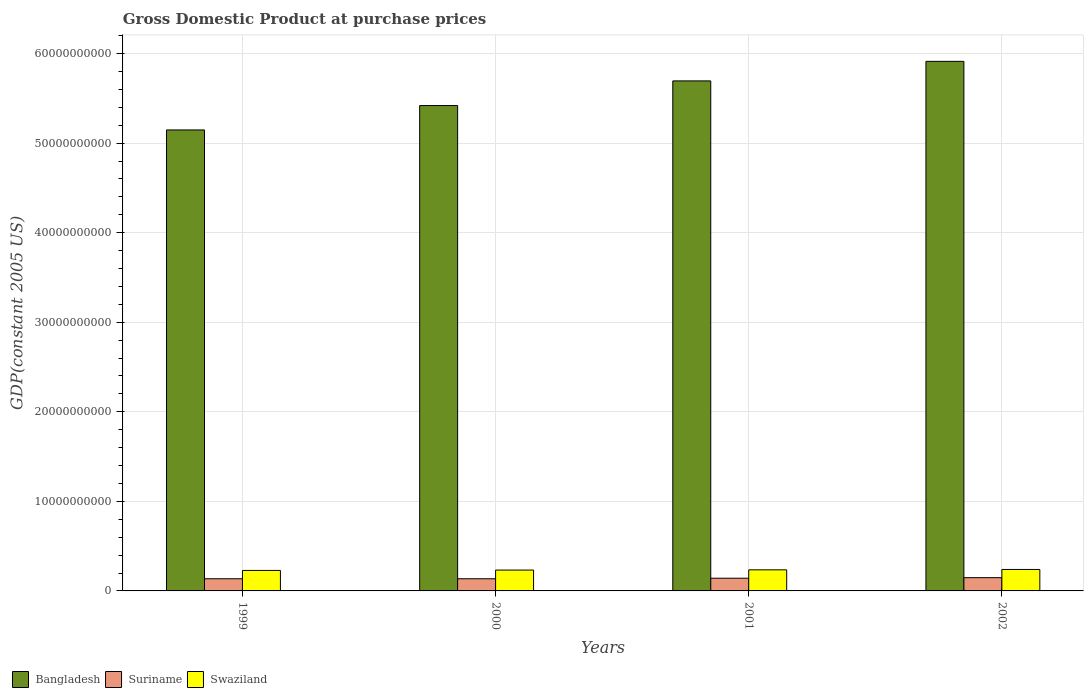How many different coloured bars are there?
Ensure brevity in your answer.  3. Are the number of bars on each tick of the X-axis equal?
Keep it short and to the point. Yes. How many bars are there on the 1st tick from the right?
Provide a succinct answer. 3. In how many cases, is the number of bars for a given year not equal to the number of legend labels?
Your answer should be very brief. 0. What is the GDP at purchase prices in Bangladesh in 1999?
Your answer should be very brief. 5.15e+1. Across all years, what is the maximum GDP at purchase prices in Swaziland?
Your answer should be compact. 2.40e+09. Across all years, what is the minimum GDP at purchase prices in Suriname?
Keep it short and to the point. 1.36e+09. In which year was the GDP at purchase prices in Suriname minimum?
Offer a very short reply. 2000. What is the total GDP at purchase prices in Swaziland in the graph?
Your answer should be compact. 9.37e+09. What is the difference between the GDP at purchase prices in Bangladesh in 1999 and that in 2001?
Offer a terse response. -5.48e+09. What is the difference between the GDP at purchase prices in Bangladesh in 2002 and the GDP at purchase prices in Suriname in 1999?
Ensure brevity in your answer.  5.78e+1. What is the average GDP at purchase prices in Suriname per year?
Keep it short and to the point. 1.40e+09. In the year 2000, what is the difference between the GDP at purchase prices in Suriname and GDP at purchase prices in Bangladesh?
Your answer should be very brief. -5.28e+1. What is the ratio of the GDP at purchase prices in Suriname in 2001 to that in 2002?
Provide a succinct answer. 0.96. Is the difference between the GDP at purchase prices in Suriname in 2000 and 2001 greater than the difference between the GDP at purchase prices in Bangladesh in 2000 and 2001?
Keep it short and to the point. Yes. What is the difference between the highest and the second highest GDP at purchase prices in Bangladesh?
Ensure brevity in your answer.  2.18e+09. What is the difference between the highest and the lowest GDP at purchase prices in Bangladesh?
Offer a very short reply. 7.66e+09. In how many years, is the GDP at purchase prices in Suriname greater than the average GDP at purchase prices in Suriname taken over all years?
Provide a succinct answer. 2. Is the sum of the GDP at purchase prices in Bangladesh in 1999 and 2002 greater than the maximum GDP at purchase prices in Suriname across all years?
Provide a short and direct response. Yes. What does the 3rd bar from the left in 2001 represents?
Offer a terse response. Swaziland. What does the 1st bar from the right in 2001 represents?
Your response must be concise. Swaziland. Are all the bars in the graph horizontal?
Your answer should be compact. No. What is the difference between two consecutive major ticks on the Y-axis?
Your answer should be very brief. 1.00e+1. Where does the legend appear in the graph?
Your response must be concise. Bottom left. How many legend labels are there?
Give a very brief answer. 3. How are the legend labels stacked?
Your response must be concise. Horizontal. What is the title of the graph?
Your answer should be very brief. Gross Domestic Product at purchase prices. Does "Peru" appear as one of the legend labels in the graph?
Make the answer very short. No. What is the label or title of the Y-axis?
Provide a short and direct response. GDP(constant 2005 US). What is the GDP(constant 2005 US) in Bangladesh in 1999?
Your answer should be very brief. 5.15e+1. What is the GDP(constant 2005 US) in Suriname in 1999?
Keep it short and to the point. 1.36e+09. What is the GDP(constant 2005 US) in Swaziland in 1999?
Your response must be concise. 2.29e+09. What is the GDP(constant 2005 US) of Bangladesh in 2000?
Make the answer very short. 5.42e+1. What is the GDP(constant 2005 US) in Suriname in 2000?
Your answer should be compact. 1.36e+09. What is the GDP(constant 2005 US) in Swaziland in 2000?
Keep it short and to the point. 2.33e+09. What is the GDP(constant 2005 US) of Bangladesh in 2001?
Make the answer very short. 5.70e+1. What is the GDP(constant 2005 US) of Suriname in 2001?
Your answer should be very brief. 1.42e+09. What is the GDP(constant 2005 US) of Swaziland in 2001?
Ensure brevity in your answer.  2.36e+09. What is the GDP(constant 2005 US) of Bangladesh in 2002?
Your answer should be compact. 5.91e+1. What is the GDP(constant 2005 US) of Suriname in 2002?
Your answer should be compact. 1.48e+09. What is the GDP(constant 2005 US) in Swaziland in 2002?
Keep it short and to the point. 2.40e+09. Across all years, what is the maximum GDP(constant 2005 US) in Bangladesh?
Keep it short and to the point. 5.91e+1. Across all years, what is the maximum GDP(constant 2005 US) in Suriname?
Offer a terse response. 1.48e+09. Across all years, what is the maximum GDP(constant 2005 US) in Swaziland?
Offer a very short reply. 2.40e+09. Across all years, what is the minimum GDP(constant 2005 US) of Bangladesh?
Ensure brevity in your answer.  5.15e+1. Across all years, what is the minimum GDP(constant 2005 US) in Suriname?
Your response must be concise. 1.36e+09. Across all years, what is the minimum GDP(constant 2005 US) in Swaziland?
Give a very brief answer. 2.29e+09. What is the total GDP(constant 2005 US) of Bangladesh in the graph?
Offer a very short reply. 2.22e+11. What is the total GDP(constant 2005 US) in Suriname in the graph?
Provide a short and direct response. 5.62e+09. What is the total GDP(constant 2005 US) of Swaziland in the graph?
Offer a very short reply. 9.37e+09. What is the difference between the GDP(constant 2005 US) in Bangladesh in 1999 and that in 2000?
Your answer should be compact. -2.72e+09. What is the difference between the GDP(constant 2005 US) in Suriname in 1999 and that in 2000?
Give a very brief answer. 9.34e+05. What is the difference between the GDP(constant 2005 US) of Swaziland in 1999 and that in 2000?
Keep it short and to the point. -4.03e+07. What is the difference between the GDP(constant 2005 US) of Bangladesh in 1999 and that in 2001?
Your response must be concise. -5.48e+09. What is the difference between the GDP(constant 2005 US) of Suriname in 1999 and that in 2001?
Give a very brief answer. -6.09e+07. What is the difference between the GDP(constant 2005 US) of Swaziland in 1999 and that in 2001?
Make the answer very short. -6.72e+07. What is the difference between the GDP(constant 2005 US) of Bangladesh in 1999 and that in 2002?
Offer a very short reply. -7.66e+09. What is the difference between the GDP(constant 2005 US) in Suriname in 1999 and that in 2002?
Provide a succinct answer. -1.22e+08. What is the difference between the GDP(constant 2005 US) of Swaziland in 1999 and that in 2002?
Give a very brief answer. -1.09e+08. What is the difference between the GDP(constant 2005 US) in Bangladesh in 2000 and that in 2001?
Give a very brief answer. -2.75e+09. What is the difference between the GDP(constant 2005 US) of Suriname in 2000 and that in 2001?
Provide a short and direct response. -6.18e+07. What is the difference between the GDP(constant 2005 US) in Swaziland in 2000 and that in 2001?
Offer a very short reply. -2.70e+07. What is the difference between the GDP(constant 2005 US) of Bangladesh in 2000 and that in 2002?
Ensure brevity in your answer.  -4.93e+09. What is the difference between the GDP(constant 2005 US) in Suriname in 2000 and that in 2002?
Offer a very short reply. -1.23e+08. What is the difference between the GDP(constant 2005 US) of Swaziland in 2000 and that in 2002?
Make the answer very short. -6.88e+07. What is the difference between the GDP(constant 2005 US) in Bangladesh in 2001 and that in 2002?
Give a very brief answer. -2.18e+09. What is the difference between the GDP(constant 2005 US) of Suriname in 2001 and that in 2002?
Offer a terse response. -6.11e+07. What is the difference between the GDP(constant 2005 US) of Swaziland in 2001 and that in 2002?
Offer a terse response. -4.19e+07. What is the difference between the GDP(constant 2005 US) in Bangladesh in 1999 and the GDP(constant 2005 US) in Suriname in 2000?
Your answer should be compact. 5.01e+1. What is the difference between the GDP(constant 2005 US) in Bangladesh in 1999 and the GDP(constant 2005 US) in Swaziland in 2000?
Offer a very short reply. 4.91e+1. What is the difference between the GDP(constant 2005 US) of Suriname in 1999 and the GDP(constant 2005 US) of Swaziland in 2000?
Provide a succinct answer. -9.69e+08. What is the difference between the GDP(constant 2005 US) in Bangladesh in 1999 and the GDP(constant 2005 US) in Suriname in 2001?
Make the answer very short. 5.01e+1. What is the difference between the GDP(constant 2005 US) of Bangladesh in 1999 and the GDP(constant 2005 US) of Swaziland in 2001?
Offer a very short reply. 4.91e+1. What is the difference between the GDP(constant 2005 US) in Suriname in 1999 and the GDP(constant 2005 US) in Swaziland in 2001?
Make the answer very short. -9.96e+08. What is the difference between the GDP(constant 2005 US) in Bangladesh in 1999 and the GDP(constant 2005 US) in Suriname in 2002?
Your answer should be compact. 5.00e+1. What is the difference between the GDP(constant 2005 US) of Bangladesh in 1999 and the GDP(constant 2005 US) of Swaziland in 2002?
Offer a very short reply. 4.91e+1. What is the difference between the GDP(constant 2005 US) in Suriname in 1999 and the GDP(constant 2005 US) in Swaziland in 2002?
Provide a succinct answer. -1.04e+09. What is the difference between the GDP(constant 2005 US) of Bangladesh in 2000 and the GDP(constant 2005 US) of Suriname in 2001?
Your answer should be very brief. 5.28e+1. What is the difference between the GDP(constant 2005 US) of Bangladesh in 2000 and the GDP(constant 2005 US) of Swaziland in 2001?
Your answer should be compact. 5.18e+1. What is the difference between the GDP(constant 2005 US) of Suriname in 2000 and the GDP(constant 2005 US) of Swaziland in 2001?
Provide a short and direct response. -9.97e+08. What is the difference between the GDP(constant 2005 US) in Bangladesh in 2000 and the GDP(constant 2005 US) in Suriname in 2002?
Provide a short and direct response. 5.27e+1. What is the difference between the GDP(constant 2005 US) in Bangladesh in 2000 and the GDP(constant 2005 US) in Swaziland in 2002?
Offer a terse response. 5.18e+1. What is the difference between the GDP(constant 2005 US) of Suriname in 2000 and the GDP(constant 2005 US) of Swaziland in 2002?
Keep it short and to the point. -1.04e+09. What is the difference between the GDP(constant 2005 US) in Bangladesh in 2001 and the GDP(constant 2005 US) in Suriname in 2002?
Your answer should be very brief. 5.55e+1. What is the difference between the GDP(constant 2005 US) in Bangladesh in 2001 and the GDP(constant 2005 US) in Swaziland in 2002?
Give a very brief answer. 5.46e+1. What is the difference between the GDP(constant 2005 US) of Suriname in 2001 and the GDP(constant 2005 US) of Swaziland in 2002?
Provide a succinct answer. -9.77e+08. What is the average GDP(constant 2005 US) in Bangladesh per year?
Your response must be concise. 5.54e+1. What is the average GDP(constant 2005 US) in Suriname per year?
Provide a short and direct response. 1.40e+09. What is the average GDP(constant 2005 US) of Swaziland per year?
Provide a short and direct response. 2.34e+09. In the year 1999, what is the difference between the GDP(constant 2005 US) of Bangladesh and GDP(constant 2005 US) of Suriname?
Offer a very short reply. 5.01e+1. In the year 1999, what is the difference between the GDP(constant 2005 US) of Bangladesh and GDP(constant 2005 US) of Swaziland?
Offer a terse response. 4.92e+1. In the year 1999, what is the difference between the GDP(constant 2005 US) in Suriname and GDP(constant 2005 US) in Swaziland?
Make the answer very short. -9.29e+08. In the year 2000, what is the difference between the GDP(constant 2005 US) in Bangladesh and GDP(constant 2005 US) in Suriname?
Your answer should be compact. 5.28e+1. In the year 2000, what is the difference between the GDP(constant 2005 US) in Bangladesh and GDP(constant 2005 US) in Swaziland?
Provide a succinct answer. 5.19e+1. In the year 2000, what is the difference between the GDP(constant 2005 US) in Suriname and GDP(constant 2005 US) in Swaziland?
Provide a succinct answer. -9.70e+08. In the year 2001, what is the difference between the GDP(constant 2005 US) in Bangladesh and GDP(constant 2005 US) in Suriname?
Give a very brief answer. 5.55e+1. In the year 2001, what is the difference between the GDP(constant 2005 US) in Bangladesh and GDP(constant 2005 US) in Swaziland?
Your answer should be very brief. 5.46e+1. In the year 2001, what is the difference between the GDP(constant 2005 US) in Suriname and GDP(constant 2005 US) in Swaziland?
Ensure brevity in your answer.  -9.35e+08. In the year 2002, what is the difference between the GDP(constant 2005 US) of Bangladesh and GDP(constant 2005 US) of Suriname?
Your answer should be very brief. 5.77e+1. In the year 2002, what is the difference between the GDP(constant 2005 US) of Bangladesh and GDP(constant 2005 US) of Swaziland?
Provide a succinct answer. 5.67e+1. In the year 2002, what is the difference between the GDP(constant 2005 US) of Suriname and GDP(constant 2005 US) of Swaziland?
Offer a terse response. -9.16e+08. What is the ratio of the GDP(constant 2005 US) of Bangladesh in 1999 to that in 2000?
Offer a terse response. 0.95. What is the ratio of the GDP(constant 2005 US) of Swaziland in 1999 to that in 2000?
Make the answer very short. 0.98. What is the ratio of the GDP(constant 2005 US) of Bangladesh in 1999 to that in 2001?
Your answer should be compact. 0.9. What is the ratio of the GDP(constant 2005 US) of Suriname in 1999 to that in 2001?
Keep it short and to the point. 0.96. What is the ratio of the GDP(constant 2005 US) of Swaziland in 1999 to that in 2001?
Ensure brevity in your answer.  0.97. What is the ratio of the GDP(constant 2005 US) in Bangladesh in 1999 to that in 2002?
Your response must be concise. 0.87. What is the ratio of the GDP(constant 2005 US) of Suriname in 1999 to that in 2002?
Make the answer very short. 0.92. What is the ratio of the GDP(constant 2005 US) of Swaziland in 1999 to that in 2002?
Offer a terse response. 0.95. What is the ratio of the GDP(constant 2005 US) of Bangladesh in 2000 to that in 2001?
Make the answer very short. 0.95. What is the ratio of the GDP(constant 2005 US) in Suriname in 2000 to that in 2001?
Your response must be concise. 0.96. What is the ratio of the GDP(constant 2005 US) of Bangladesh in 2000 to that in 2002?
Offer a terse response. 0.92. What is the ratio of the GDP(constant 2005 US) of Suriname in 2000 to that in 2002?
Offer a terse response. 0.92. What is the ratio of the GDP(constant 2005 US) in Swaziland in 2000 to that in 2002?
Offer a terse response. 0.97. What is the ratio of the GDP(constant 2005 US) in Bangladesh in 2001 to that in 2002?
Give a very brief answer. 0.96. What is the ratio of the GDP(constant 2005 US) in Suriname in 2001 to that in 2002?
Offer a terse response. 0.96. What is the ratio of the GDP(constant 2005 US) of Swaziland in 2001 to that in 2002?
Provide a short and direct response. 0.98. What is the difference between the highest and the second highest GDP(constant 2005 US) of Bangladesh?
Your answer should be compact. 2.18e+09. What is the difference between the highest and the second highest GDP(constant 2005 US) in Suriname?
Offer a very short reply. 6.11e+07. What is the difference between the highest and the second highest GDP(constant 2005 US) in Swaziland?
Provide a short and direct response. 4.19e+07. What is the difference between the highest and the lowest GDP(constant 2005 US) in Bangladesh?
Provide a succinct answer. 7.66e+09. What is the difference between the highest and the lowest GDP(constant 2005 US) in Suriname?
Make the answer very short. 1.23e+08. What is the difference between the highest and the lowest GDP(constant 2005 US) of Swaziland?
Offer a very short reply. 1.09e+08. 